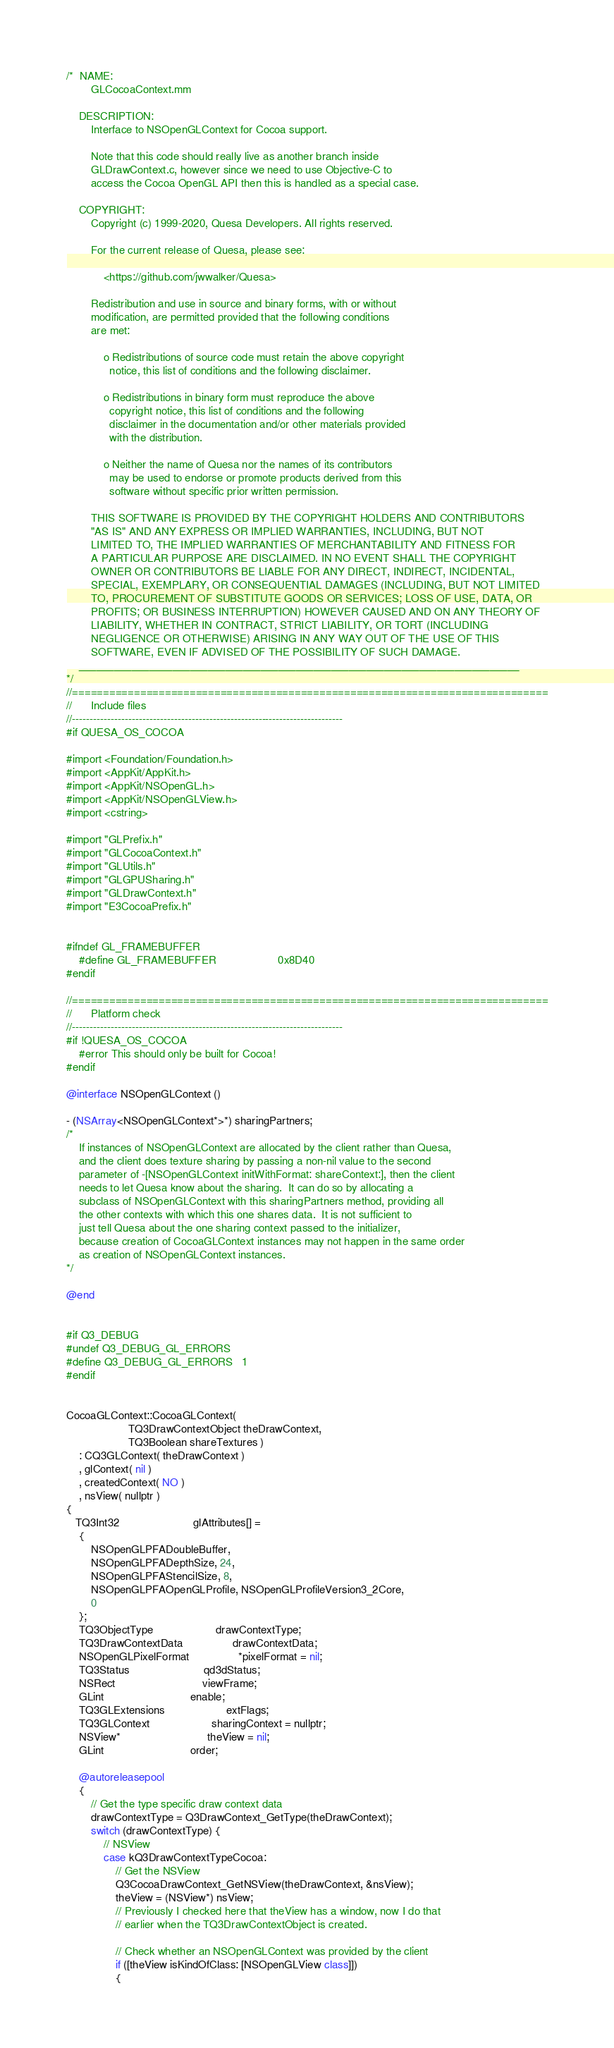Convert code to text. <code><loc_0><loc_0><loc_500><loc_500><_ObjectiveC_>/*  NAME:
        GLCocoaContext.mm

    DESCRIPTION:
        Interface to NSOpenGLContext for Cocoa support.
        
        Note that this code should really live as another branch inside
        GLDrawContext.c, however since we need to use Objective-C to
        access the Cocoa OpenGL API then this is handled as a special case.

    COPYRIGHT:
        Copyright (c) 1999-2020, Quesa Developers. All rights reserved.

        For the current release of Quesa, please see:

            <https://github.com/jwwalker/Quesa>
        
        Redistribution and use in source and binary forms, with or without
        modification, are permitted provided that the following conditions
        are met:
        
            o Redistributions of source code must retain the above copyright
              notice, this list of conditions and the following disclaimer.
        
            o Redistributions in binary form must reproduce the above
              copyright notice, this list of conditions and the following
              disclaimer in the documentation and/or other materials provided
              with the distribution.
        
            o Neither the name of Quesa nor the names of its contributors
              may be used to endorse or promote products derived from this
              software without specific prior written permission.
        
        THIS SOFTWARE IS PROVIDED BY THE COPYRIGHT HOLDERS AND CONTRIBUTORS
        "AS IS" AND ANY EXPRESS OR IMPLIED WARRANTIES, INCLUDING, BUT NOT
        LIMITED TO, THE IMPLIED WARRANTIES OF MERCHANTABILITY AND FITNESS FOR
        A PARTICULAR PURPOSE ARE DISCLAIMED. IN NO EVENT SHALL THE COPYRIGHT
        OWNER OR CONTRIBUTORS BE LIABLE FOR ANY DIRECT, INDIRECT, INCIDENTAL,
        SPECIAL, EXEMPLARY, OR CONSEQUENTIAL DAMAGES (INCLUDING, BUT NOT LIMITED
        TO, PROCUREMENT OF SUBSTITUTE GOODS OR SERVICES; LOSS OF USE, DATA, OR
        PROFITS; OR BUSINESS INTERRUPTION) HOWEVER CAUSED AND ON ANY THEORY OF
        LIABILITY, WHETHER IN CONTRACT, STRICT LIABILITY, OR TORT (INCLUDING
        NEGLIGENCE OR OTHERWISE) ARISING IN ANY WAY OUT OF THE USE OF THIS
        SOFTWARE, EVEN IF ADVISED OF THE POSSIBILITY OF SUCH DAMAGE.
    ___________________________________________________________________________
*/
//=============================================================================
//      Include files
//-----------------------------------------------------------------------------
#if QUESA_OS_COCOA

#import <Foundation/Foundation.h>
#import <AppKit/AppKit.h>
#import <AppKit/NSOpenGL.h>
#import <AppKit/NSOpenGLView.h>
#import <cstring>

#import "GLPrefix.h"
#import "GLCocoaContext.h"
#import "GLUtils.h"
#import "GLGPUSharing.h"
#import "GLDrawContext.h"
#import "E3CocoaPrefix.h"


#ifndef GL_FRAMEBUFFER
	#define GL_FRAMEBUFFER                    0x8D40
#endif

//=============================================================================
//		Platform check
//-----------------------------------------------------------------------------
#if !QUESA_OS_COCOA
	#error This should only be built for Cocoa!
#endif

@interface NSOpenGLContext ()

- (NSArray<NSOpenGLContext*>*) sharingPartners;
/*
	If instances of NSOpenGLContext are allocated by the client rather than Quesa,
	and the client does texture sharing by passing a non-nil value to the second
	parameter of -[NSOpenGLContext initWithFormat: shareContext:], then the client
	needs to let Quesa know about the sharing.  It can do so by allocating a
	subclass of NSOpenGLContext with this sharingPartners method, providing all
	the other contexts with which this one shares data.  It is not sufficient to
	just tell Quesa about the one sharing context passed to the initializer,
	because creation of CocoaGLContext instances may not happen in the same order
	as creation of NSOpenGLContext instances.
*/

@end


#if Q3_DEBUG
#undef Q3_DEBUG_GL_ERRORS
#define Q3_DEBUG_GL_ERRORS 	1
#endif


CocoaGLContext::CocoaGLContext(
					TQ3DrawContextObject theDrawContext,
					TQ3Boolean shareTextures )
	: CQ3GLContext( theDrawContext )
	, glContext( nil )
	, createdContext( NO )
	, nsView( nullptr )
{
   TQ3Int32						glAttributes[] =
	{
		NSOpenGLPFADoubleBuffer,
		NSOpenGLPFADepthSize, 24,
		NSOpenGLPFAStencilSize, 8,
		NSOpenGLPFAOpenGLProfile, NSOpenGLProfileVersion3_2Core,
		0
	};
	TQ3ObjectType					drawContextType;
	TQ3DrawContextData				drawContextData;
    NSOpenGLPixelFormat				*pixelFormat = nil;
 	TQ3Status						qd3dStatus;
    NSRect							viewFrame;
    GLint							enable;
	TQ3GLExtensions					extFlags;
	TQ3GLContext					sharingContext = nullptr;
	NSView*							theView = nil;
	GLint							order;

	@autoreleasepool
	{
		// Get the type specific draw context data
		drawContextType = Q3DrawContext_GetType(theDrawContext);
		switch (drawContextType) {
			// NSView
			case kQ3DrawContextTypeCocoa:
				// Get the NSView
				Q3CocoaDrawContext_GetNSView(theDrawContext, &nsView);
				theView = (NSView*) nsView;
				// Previously I checked here that theView has a window, now I do that
				// earlier when the TQ3DrawContextObject is created.
				
				// Check whether an NSOpenGLContext was provided by the client
				if ([theView isKindOfClass: [NSOpenGLView class]])
				{</code> 